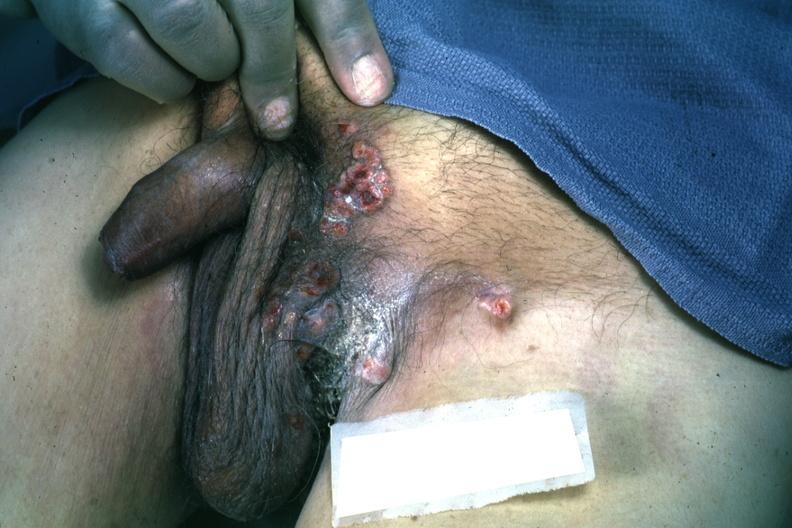does this image show multiple ulcerative lesions rectum primary excellent?
Answer the question using a single word or phrase. Yes 